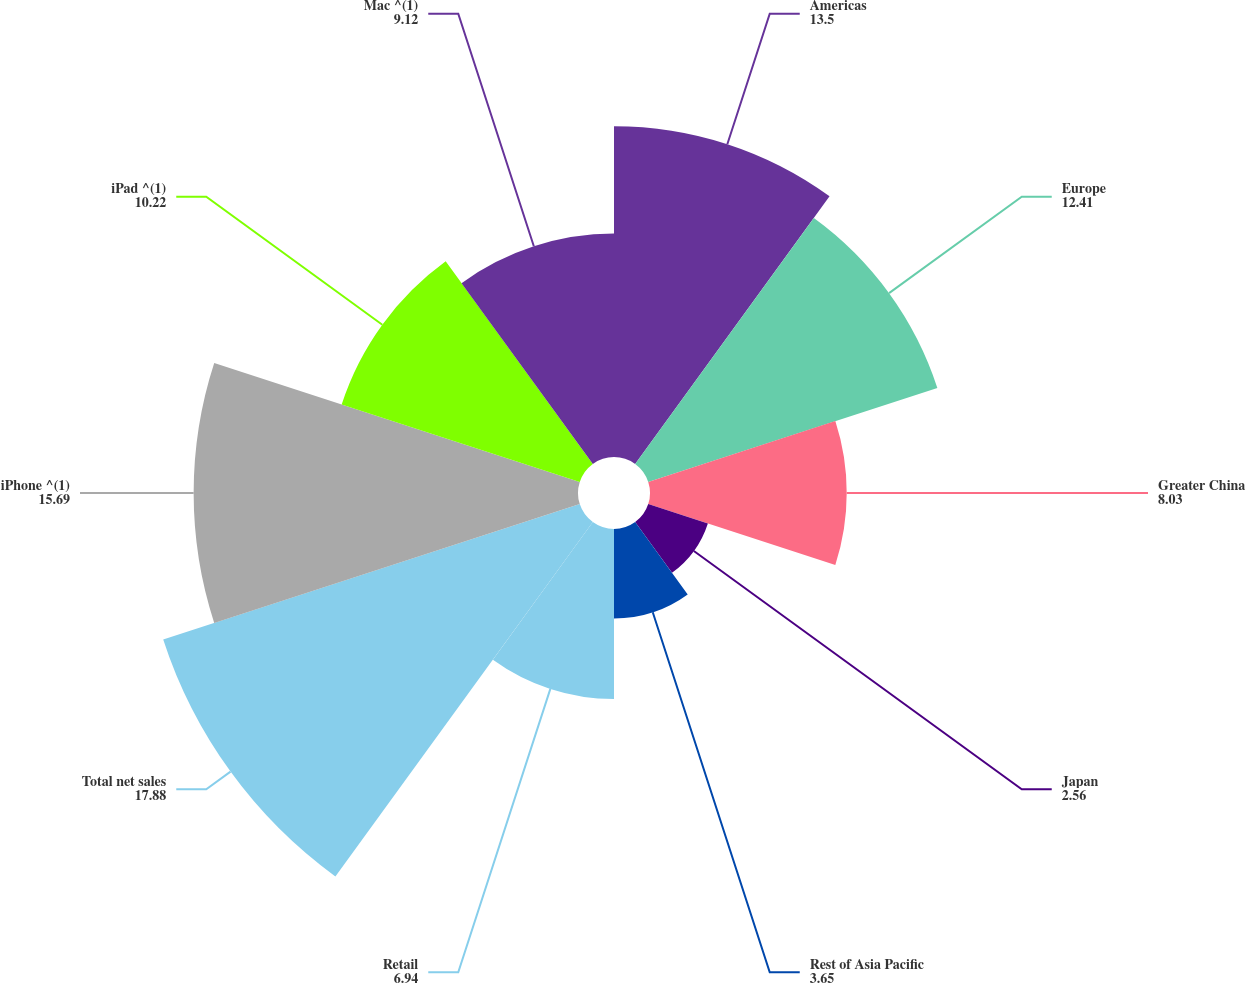Convert chart to OTSL. <chart><loc_0><loc_0><loc_500><loc_500><pie_chart><fcel>Americas<fcel>Europe<fcel>Greater China<fcel>Japan<fcel>Rest of Asia Pacific<fcel>Retail<fcel>Total net sales<fcel>iPhone ^(1)<fcel>iPad ^(1)<fcel>Mac ^(1)<nl><fcel>13.5%<fcel>12.41%<fcel>8.03%<fcel>2.56%<fcel>3.65%<fcel>6.94%<fcel>17.88%<fcel>15.69%<fcel>10.22%<fcel>9.12%<nl></chart> 